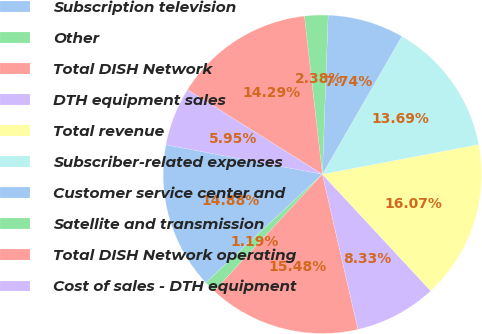<chart> <loc_0><loc_0><loc_500><loc_500><pie_chart><fcel>Subscription television<fcel>Other<fcel>Total DISH Network<fcel>DTH equipment sales<fcel>Total revenue<fcel>Subscriber-related expenses<fcel>Customer service center and<fcel>Satellite and transmission<fcel>Total DISH Network operating<fcel>Cost of sales - DTH equipment<nl><fcel>14.88%<fcel>1.19%<fcel>15.48%<fcel>8.33%<fcel>16.07%<fcel>13.69%<fcel>7.74%<fcel>2.38%<fcel>14.29%<fcel>5.95%<nl></chart> 